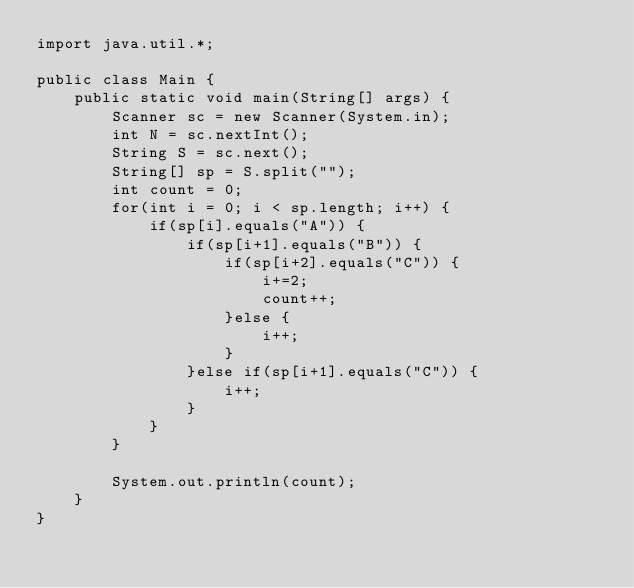<code> <loc_0><loc_0><loc_500><loc_500><_Java_>import java.util.*;
 
public class Main {
	public static void main(String[] args) {
		Scanner sc = new Scanner(System.in);
		int N = sc.nextInt();
		String S = sc.next(); 
		String[] sp = S.split("");
		int count = 0;
		for(int i = 0; i < sp.length; i++) {
		    if(sp[i].equals("A")) {
		        if(sp[i+1].equals("B")) {
                    if(sp[i+2].equals("C")) {
                        i+=2;
                        count++;
                    }else {
                        i++;
                    }
		        }else if(sp[i+1].equals("C")) {
		            i++;
		        }
            }
		}
		
		System.out.println(count);
	}
}
</code> 